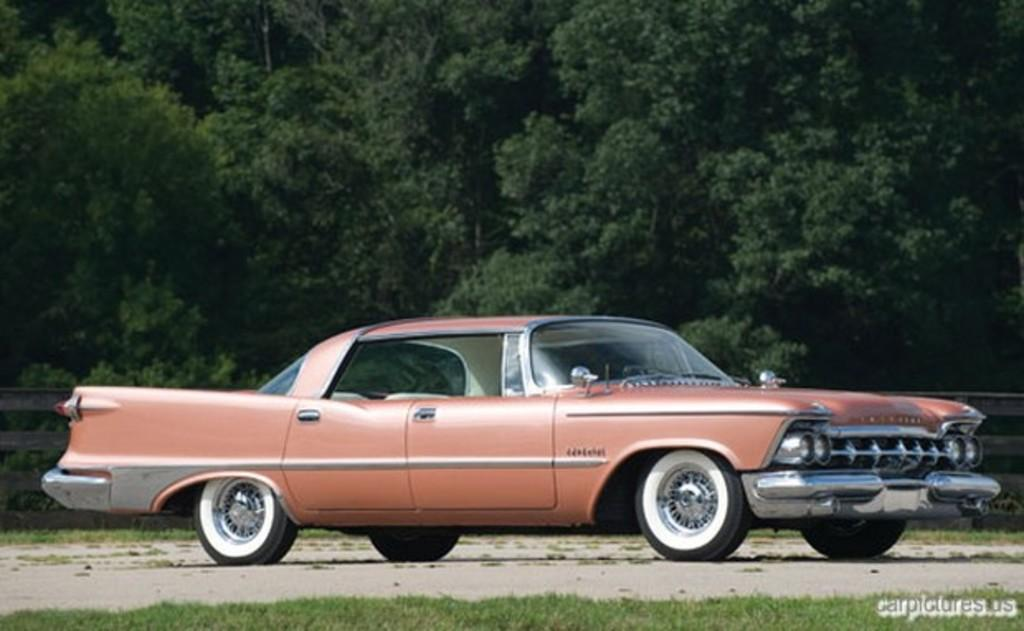What is the main subject in the center of the image? There is a car in the center of the image. Where is the car located? The car is on the road. What type of vegetation is visible at the bottom of the image? There is grass at the bottom of the image. What can be seen in the background of the image? There are trees and a fence visible in the background. What type of shoes is the dad wearing in the image? There is no dad or shoes present in the image. Does the car have a tail in the image? Cars do not have tails; they have trunks or rear ends. However, in the context of the image, the car does not have any visible appendages or features that could be described as a tail. 